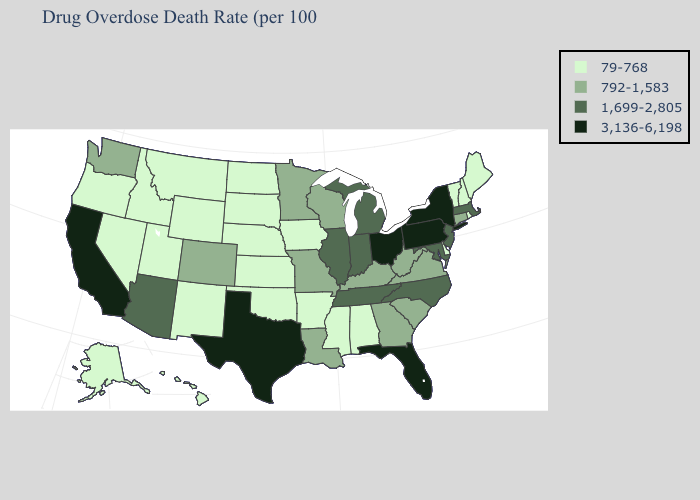Name the states that have a value in the range 79-768?
Concise answer only. Alabama, Alaska, Arkansas, Delaware, Hawaii, Idaho, Iowa, Kansas, Maine, Mississippi, Montana, Nebraska, Nevada, New Hampshire, New Mexico, North Dakota, Oklahoma, Oregon, Rhode Island, South Dakota, Utah, Vermont, Wyoming. Does Missouri have a lower value than Idaho?
Quick response, please. No. What is the highest value in the USA?
Short answer required. 3,136-6,198. Name the states that have a value in the range 792-1,583?
Be succinct. Colorado, Connecticut, Georgia, Kentucky, Louisiana, Minnesota, Missouri, South Carolina, Virginia, Washington, West Virginia, Wisconsin. Name the states that have a value in the range 792-1,583?
Quick response, please. Colorado, Connecticut, Georgia, Kentucky, Louisiana, Minnesota, Missouri, South Carolina, Virginia, Washington, West Virginia, Wisconsin. Name the states that have a value in the range 792-1,583?
Be succinct. Colorado, Connecticut, Georgia, Kentucky, Louisiana, Minnesota, Missouri, South Carolina, Virginia, Washington, West Virginia, Wisconsin. What is the value of Georgia?
Concise answer only. 792-1,583. Does Florida have the lowest value in the South?
Be succinct. No. Does Massachusetts have the lowest value in the Northeast?
Answer briefly. No. Name the states that have a value in the range 3,136-6,198?
Answer briefly. California, Florida, New York, Ohio, Pennsylvania, Texas. Name the states that have a value in the range 3,136-6,198?
Write a very short answer. California, Florida, New York, Ohio, Pennsylvania, Texas. What is the value of North Carolina?
Short answer required. 1,699-2,805. Among the states that border Pennsylvania , which have the lowest value?
Write a very short answer. Delaware. Does the map have missing data?
Give a very brief answer. No. Name the states that have a value in the range 3,136-6,198?
Quick response, please. California, Florida, New York, Ohio, Pennsylvania, Texas. 